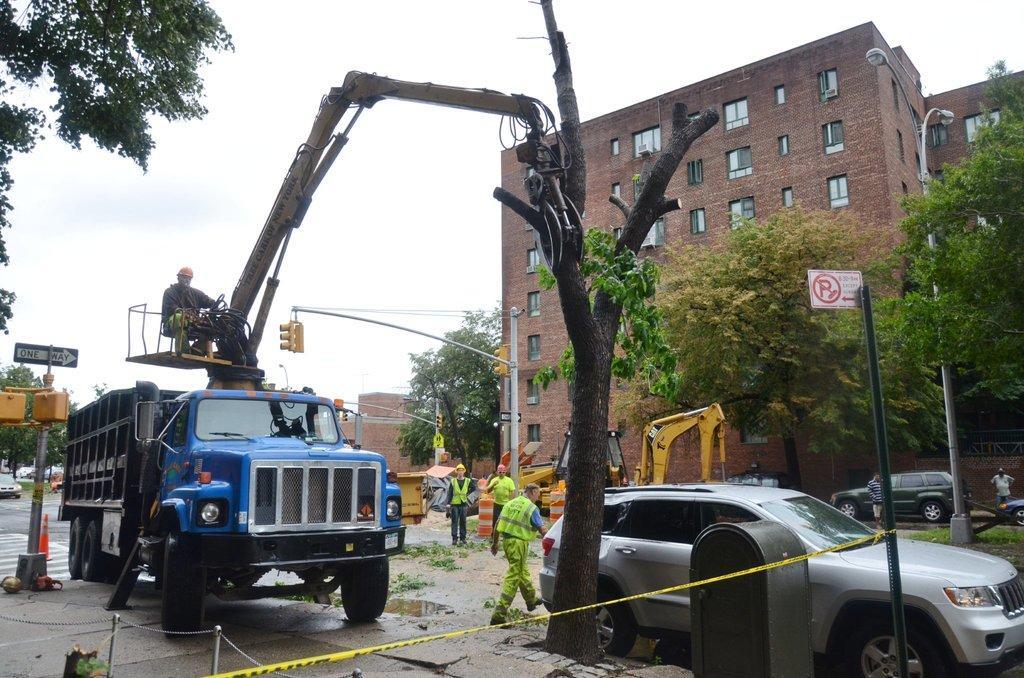In one or two sentences, can you explain what this image depicts? In the image we can see some vehicles and trees and poles and sign boards. Behind them there are some buildings and few people are standing. At the top of the image there are some clouds and sky. 